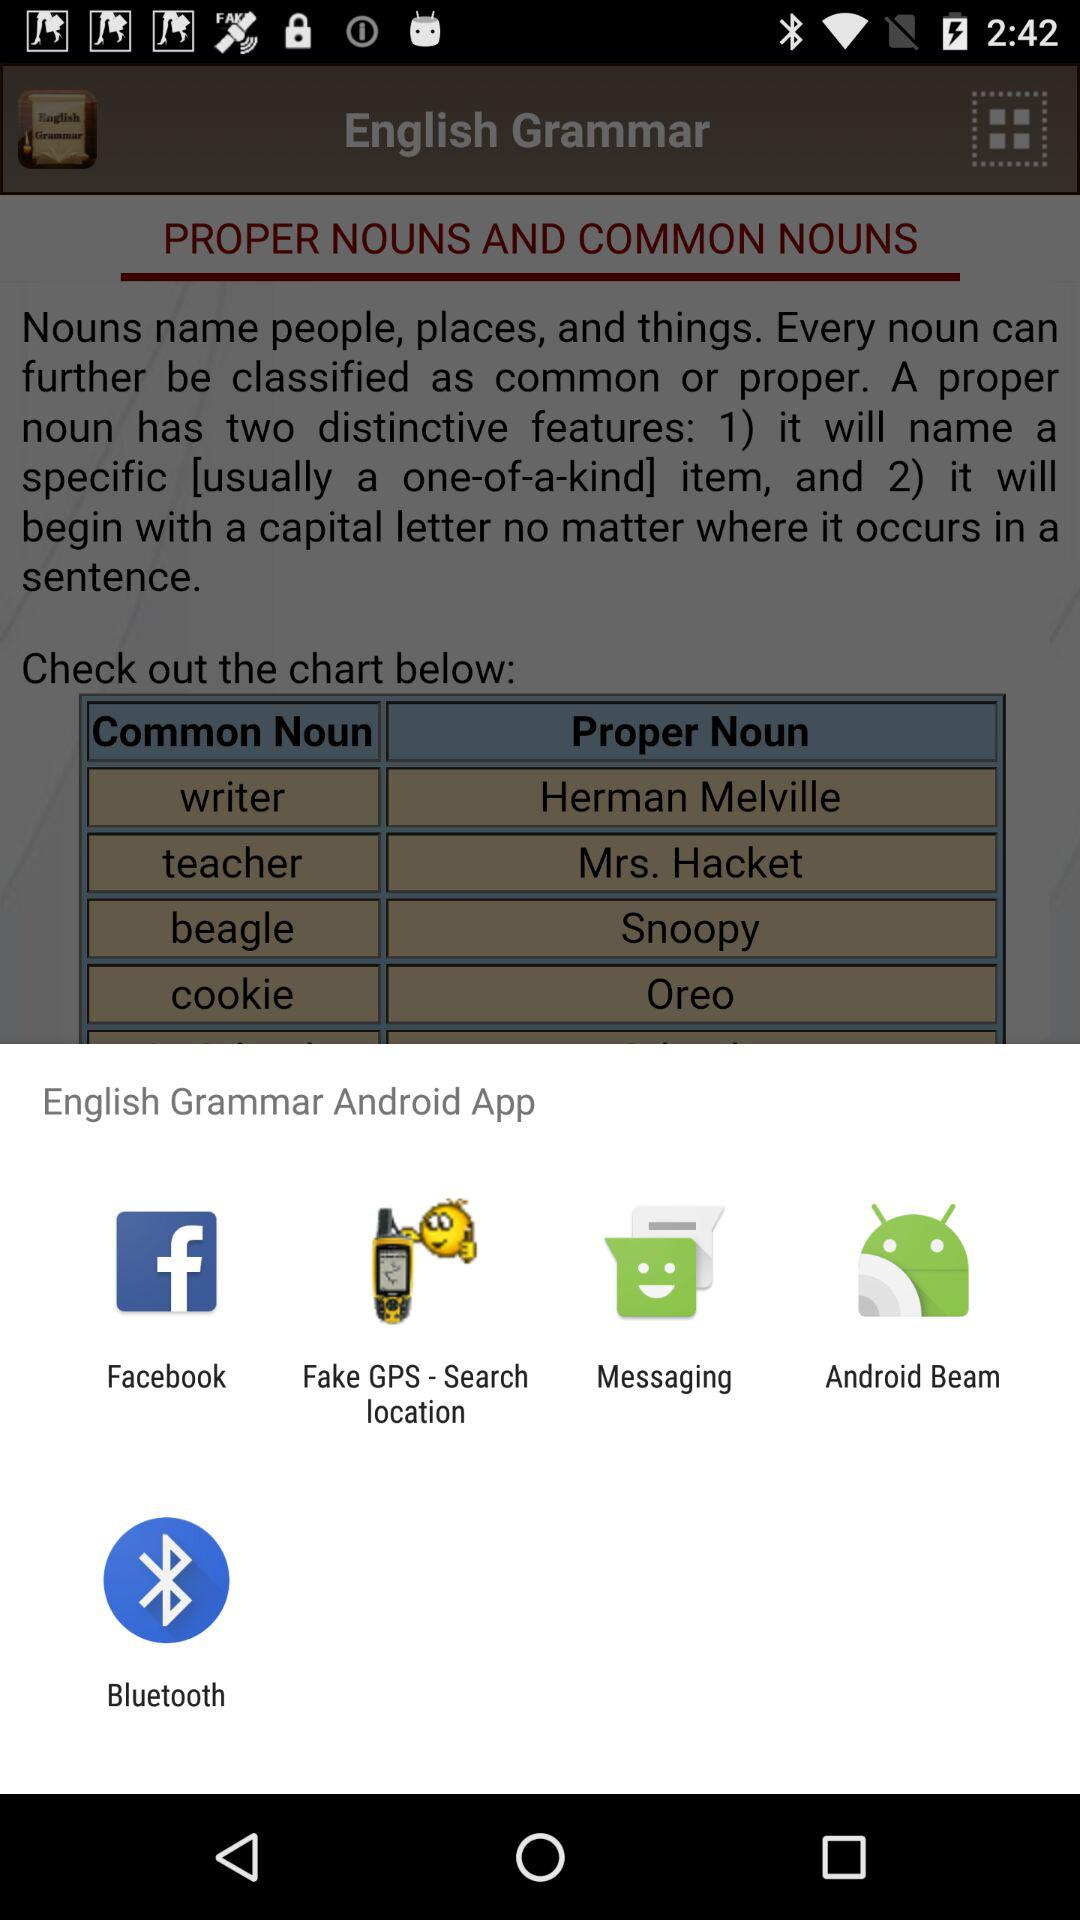Which options can be used to share the "English Grammar Android App"? The options that can be used to share the "English Grammar Android App" are "Facebook", "Fake GPS - Search location", "Messaging", "Android Beam" and "Bluetooth". 